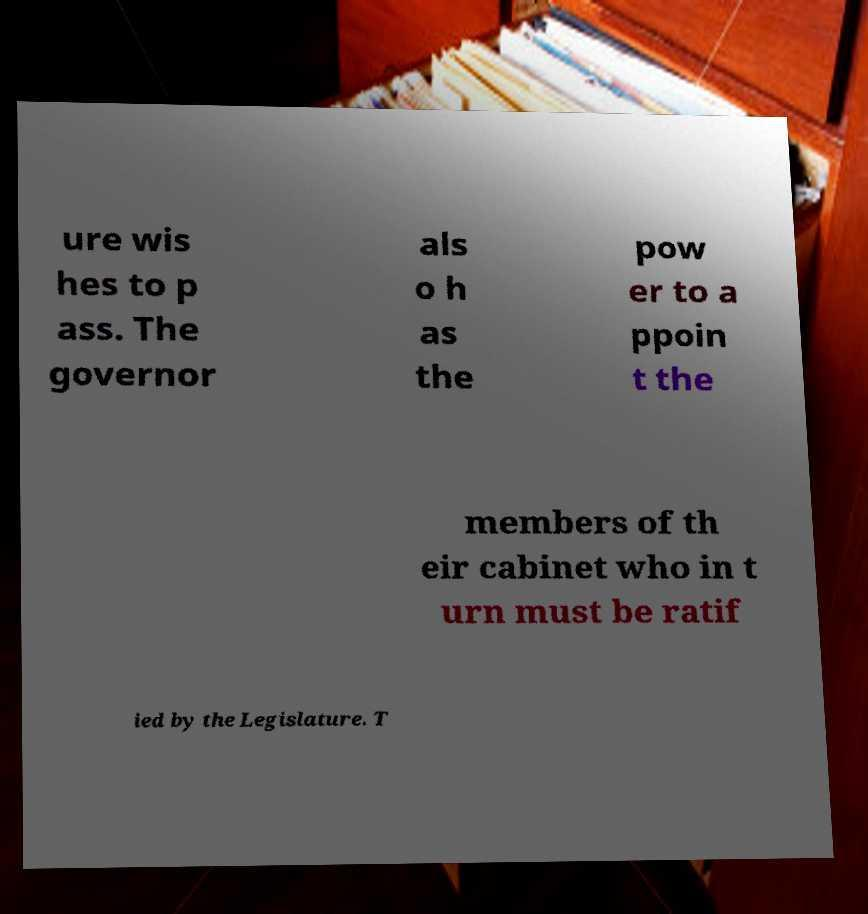Please read and relay the text visible in this image. What does it say? ure wis hes to p ass. The governor als o h as the pow er to a ppoin t the members of th eir cabinet who in t urn must be ratif ied by the Legislature. T 